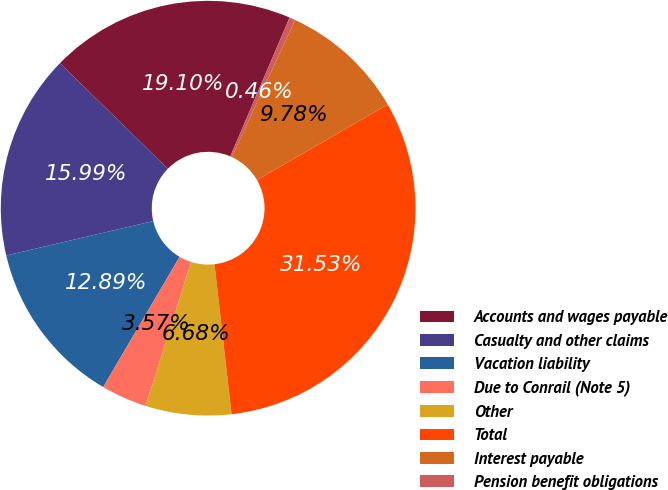Convert chart. <chart><loc_0><loc_0><loc_500><loc_500><pie_chart><fcel>Accounts and wages payable<fcel>Casualty and other claims<fcel>Vacation liability<fcel>Due to Conrail (Note 5)<fcel>Other<fcel>Total<fcel>Interest payable<fcel>Pension benefit obligations<nl><fcel>19.1%<fcel>15.99%<fcel>12.89%<fcel>3.57%<fcel>6.68%<fcel>31.53%<fcel>9.78%<fcel>0.46%<nl></chart> 